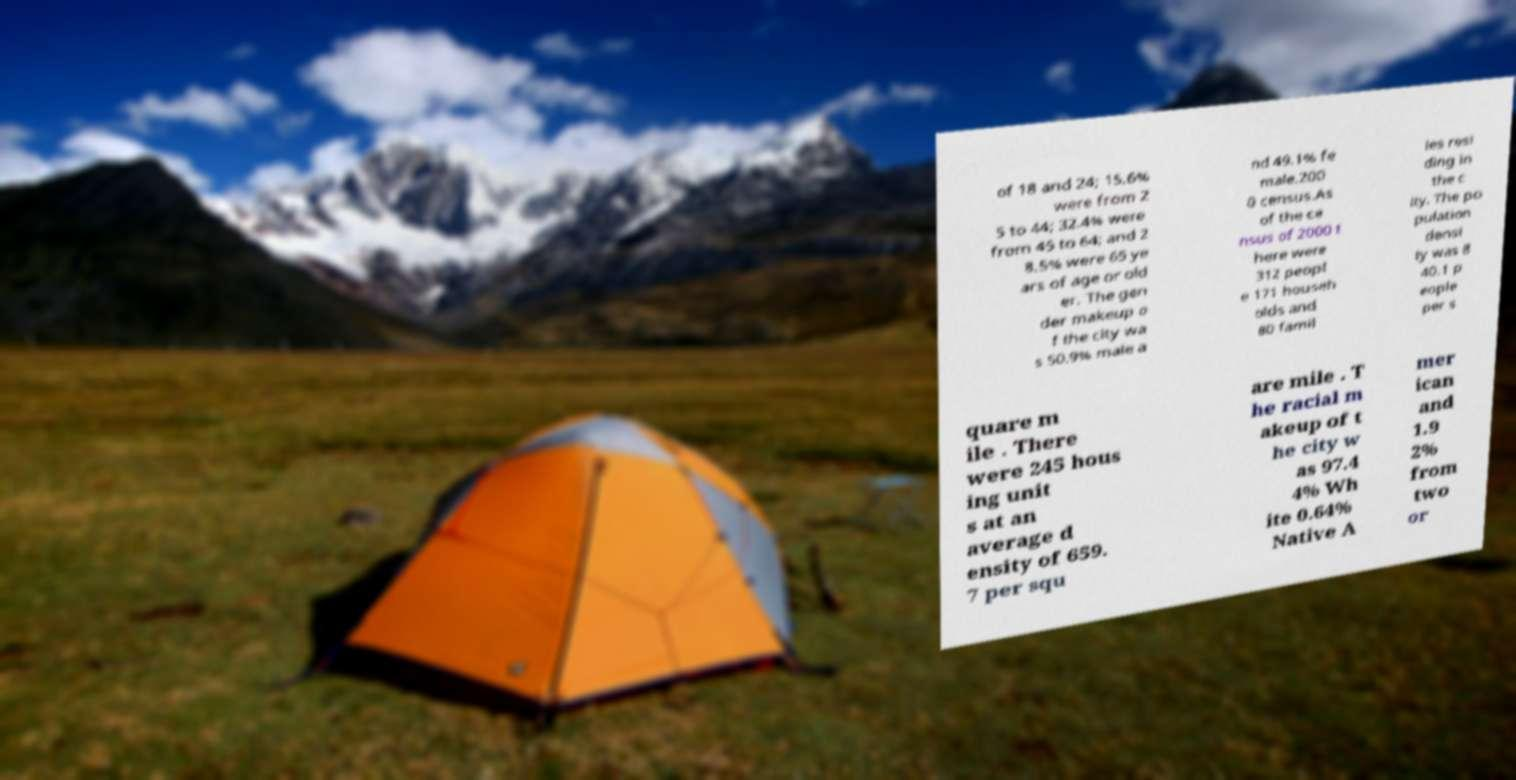There's text embedded in this image that I need extracted. Can you transcribe it verbatim? of 18 and 24; 15.6% were from 2 5 to 44; 32.4% were from 45 to 64; and 2 8.5% were 65 ye ars of age or old er. The gen der makeup o f the city wa s 50.9% male a nd 49.1% fe male.200 0 census.As of the ce nsus of 2000 t here were 312 peopl e 171 househ olds and 80 famil ies resi ding in the c ity. The po pulation densi ty was 8 40.1 p eople per s quare m ile . There were 245 hous ing unit s at an average d ensity of 659. 7 per squ are mile . T he racial m akeup of t he city w as 97.4 4% Wh ite 0.64% Native A mer ican and 1.9 2% from two or 